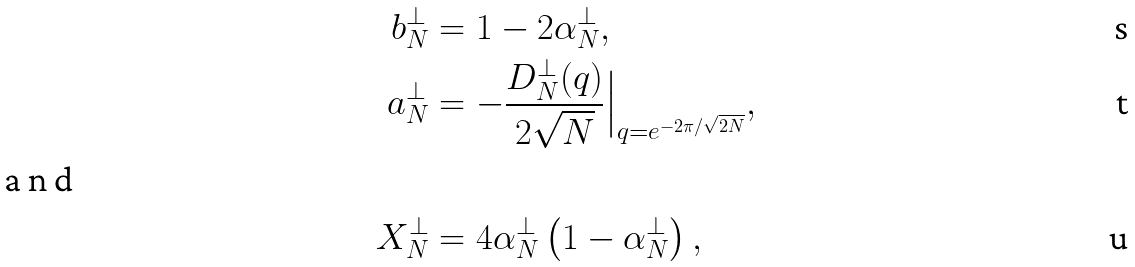Convert formula to latex. <formula><loc_0><loc_0><loc_500><loc_500>b ^ { \perp } _ { N } & = 1 - 2 \alpha _ { N } ^ { \perp } , \\ a ^ { \perp } _ { N } & = - \frac { D ^ { \perp } _ { N } ( q ) } { 2 \sqrt { N } } \Big | _ { q = e ^ { - 2 \pi / \sqrt { 2 N } } } , \\ \intertext { a n d } X ^ { \perp } _ { N } & = 4 \alpha _ { N } ^ { \perp } \left ( 1 - \alpha _ { N } ^ { \perp } \right ) ,</formula> 